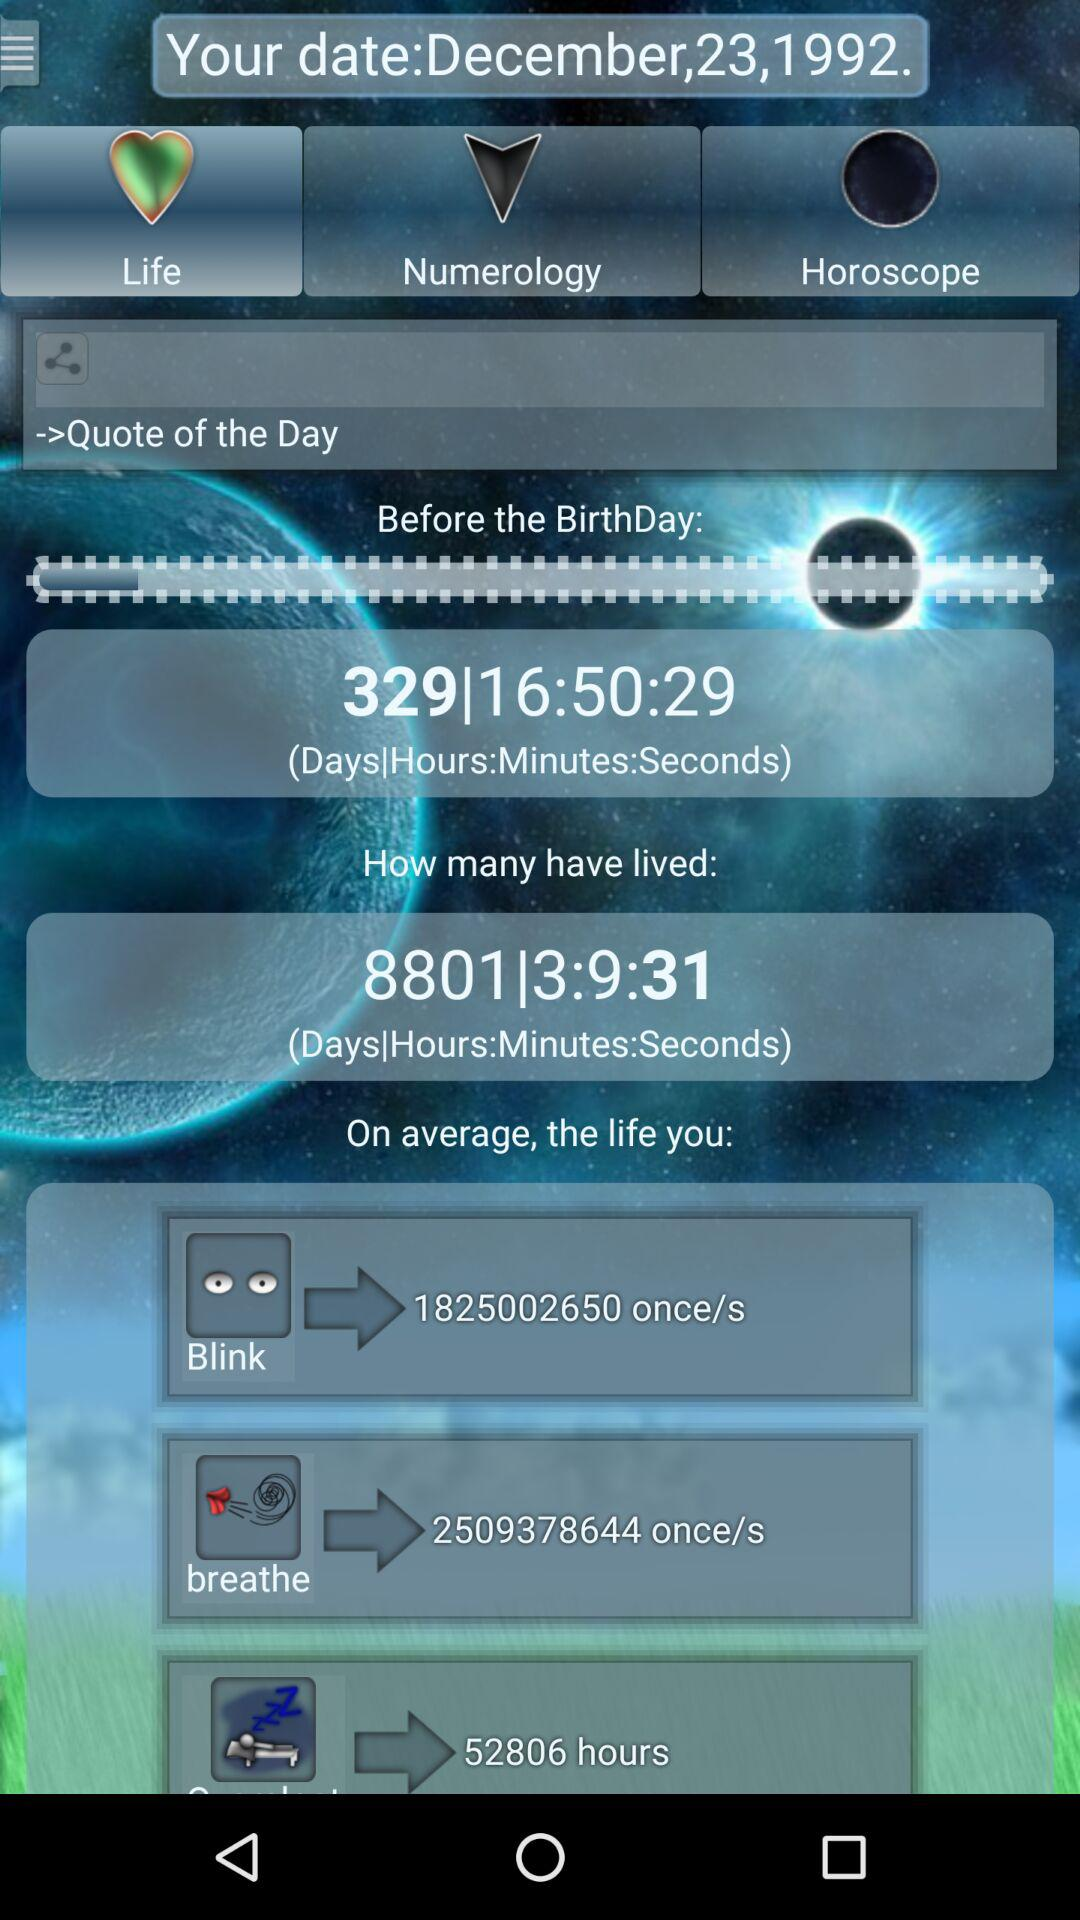What is the average blink in life? The average blink in life is 1825002650 once/s. 